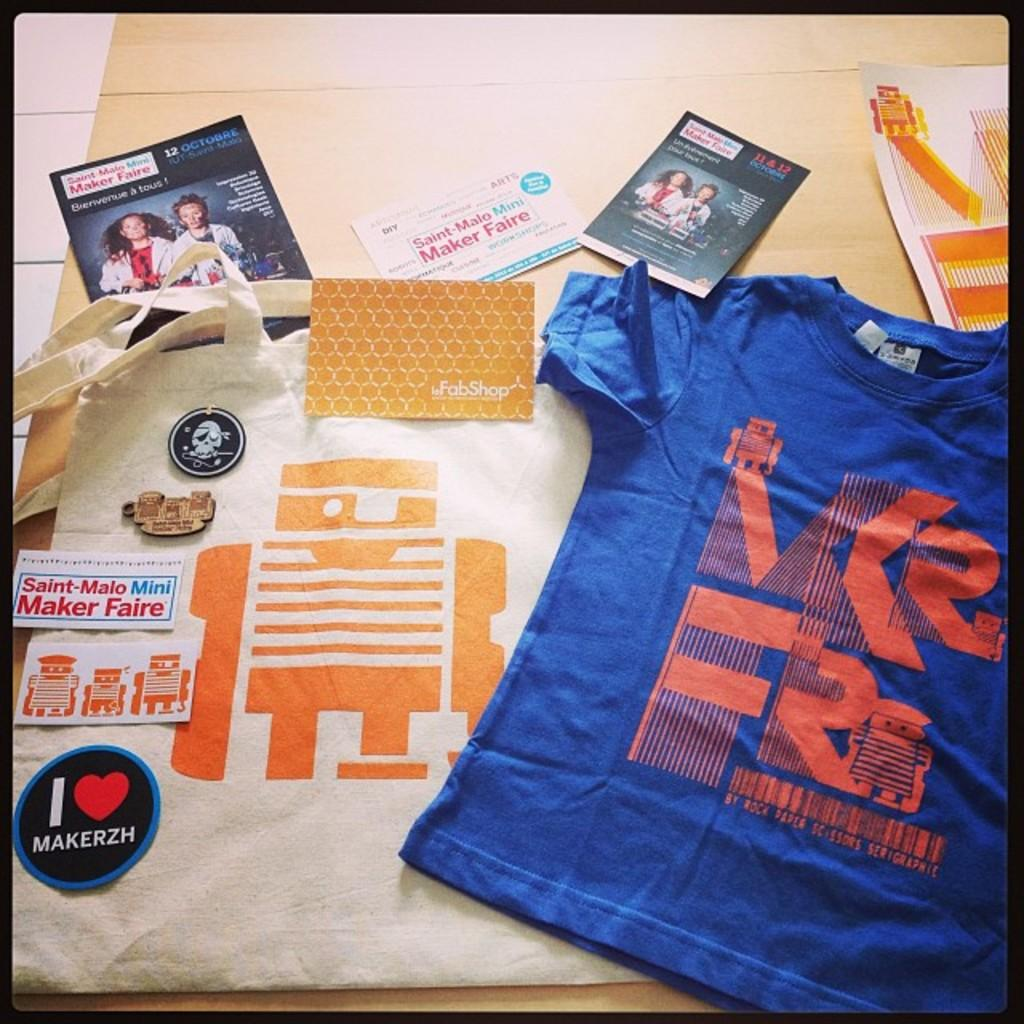How many t-shirts are visible in the image? There are two t-shirts in the image. What is on the floor in the image? There are papers on the floor in the image. What nation is responsible for the increase in the range of the t-shirts in the image? There is no information about nations, increases, or ranges in the image; it only shows two t-shirts and papers on the floor. 